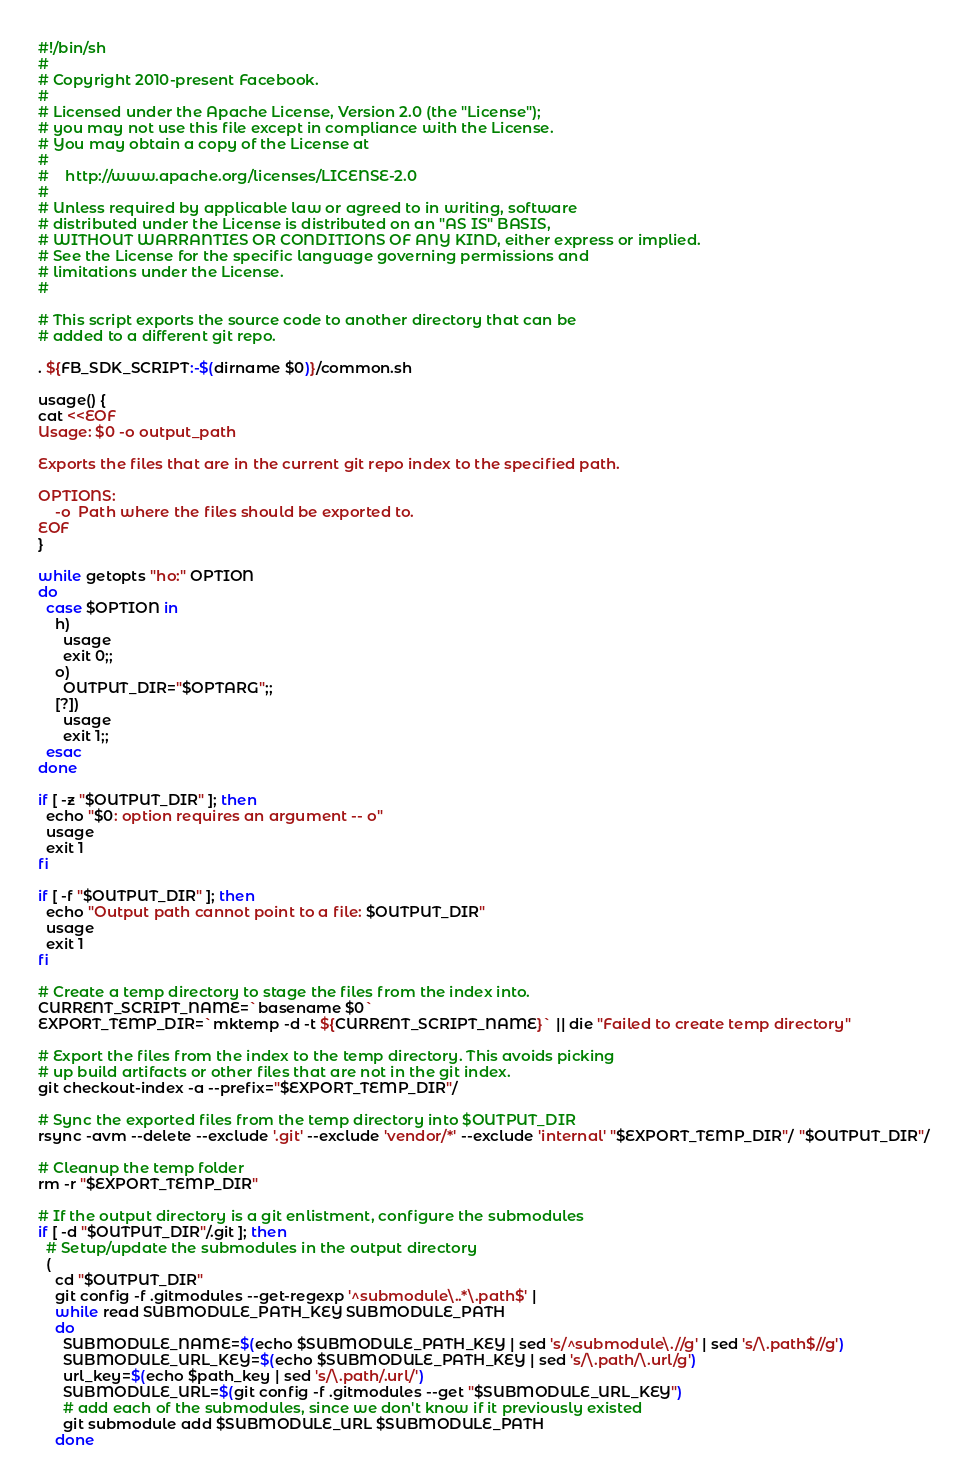Convert code to text. <code><loc_0><loc_0><loc_500><loc_500><_Bash_>#!/bin/sh
#
# Copyright 2010-present Facebook.
#
# Licensed under the Apache License, Version 2.0 (the "License");
# you may not use this file except in compliance with the License.
# You may obtain a copy of the License at
# 
#    http://www.apache.org/licenses/LICENSE-2.0
# 
# Unless required by applicable law or agreed to in writing, software
# distributed under the License is distributed on an "AS IS" BASIS,
# WITHOUT WARRANTIES OR CONDITIONS OF ANY KIND, either express or implied.
# See the License for the specific language governing permissions and
# limitations under the License.
#

# This script exports the source code to another directory that can be
# added to a different git repo.

. ${FB_SDK_SCRIPT:-$(dirname $0)}/common.sh

usage() {
cat <<EOF
Usage: $0 -o output_path

Exports the files that are in the current git repo index to the specified path.

OPTIONS:
    -o  Path where the files should be exported to.
EOF
}

while getopts "ho:" OPTION
do
  case $OPTION in
    h)
      usage
      exit 0;;
    o)
      OUTPUT_DIR="$OPTARG";;
    [?])
      usage
      exit 1;;
  esac
done

if [ -z "$OUTPUT_DIR" ]; then
  echo "$0: option requires an argument -- o"
  usage
  exit 1
fi

if [ -f "$OUTPUT_DIR" ]; then
  echo "Output path cannot point to a file: $OUTPUT_DIR"
  usage
  exit 1
fi

# Create a temp directory to stage the files from the index into.
CURRENT_SCRIPT_NAME=`basename $0`
EXPORT_TEMP_DIR=`mktemp -d -t ${CURRENT_SCRIPT_NAME}` || die "Failed to create temp directory"

# Export the files from the index to the temp directory. This avoids picking
# up build artifacts or other files that are not in the git index.
git checkout-index -a --prefix="$EXPORT_TEMP_DIR"/

# Sync the exported files from the temp directory into $OUTPUT_DIR
rsync -avm --delete --exclude '.git' --exclude 'vendor/*' --exclude 'internal' "$EXPORT_TEMP_DIR"/ "$OUTPUT_DIR"/

# Cleanup the temp folder
rm -r "$EXPORT_TEMP_DIR"

# If the output directory is a git enlistment, configure the submodules
if [ -d "$OUTPUT_DIR"/.git ]; then
  # Setup/update the submodules in the output directory
  (
    cd "$OUTPUT_DIR"
    git config -f .gitmodules --get-regexp '^submodule\..*\.path$' |
    while read SUBMODULE_PATH_KEY SUBMODULE_PATH
    do
      SUBMODULE_NAME=$(echo $SUBMODULE_PATH_KEY | sed 's/^submodule\.//g' | sed 's/\.path$//g')
      SUBMODULE_URL_KEY=$(echo $SUBMODULE_PATH_KEY | sed 's/\.path/\.url/g')
      url_key=$(echo $path_key | sed 's/\.path/.url/')
      SUBMODULE_URL=$(git config -f .gitmodules --get "$SUBMODULE_URL_KEY")
      # add each of the submodules, since we don't know if it previously existed
      git submodule add $SUBMODULE_URL $SUBMODULE_PATH
    done</code> 